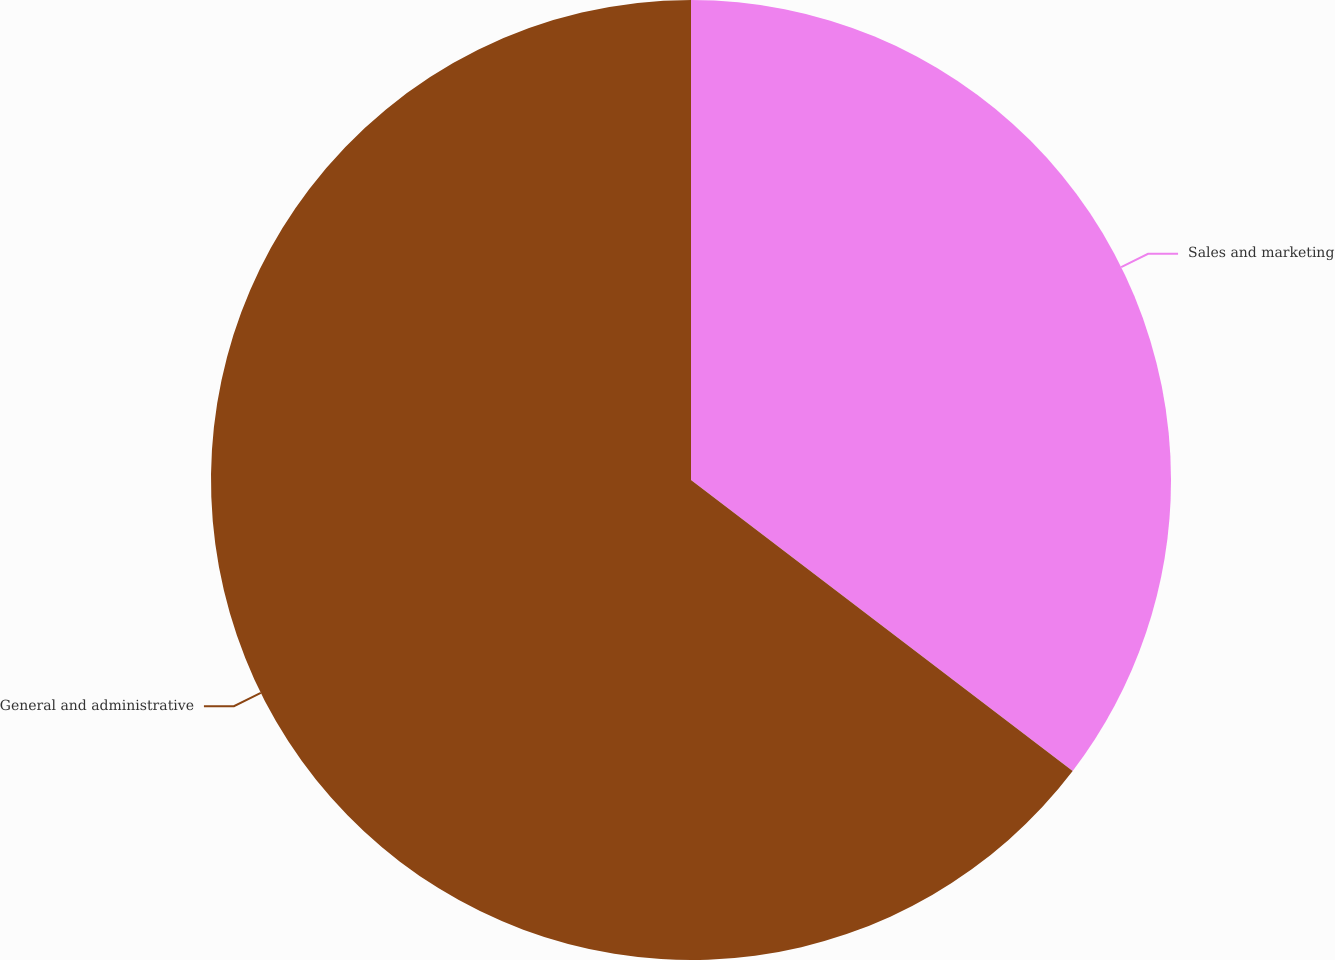Convert chart to OTSL. <chart><loc_0><loc_0><loc_500><loc_500><pie_chart><fcel>Sales and marketing<fcel>General and administrative<nl><fcel>35.37%<fcel>64.63%<nl></chart> 